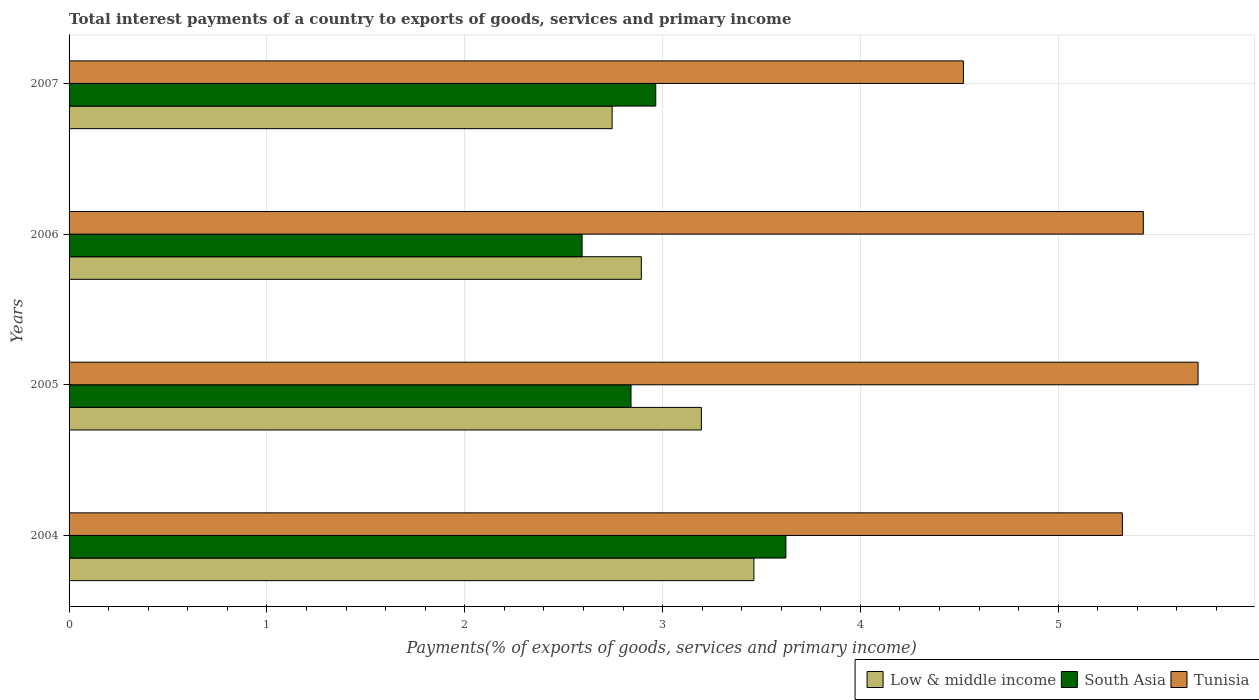How many different coloured bars are there?
Make the answer very short. 3. Are the number of bars per tick equal to the number of legend labels?
Ensure brevity in your answer.  Yes. Are the number of bars on each tick of the Y-axis equal?
Offer a terse response. Yes. How many bars are there on the 2nd tick from the top?
Make the answer very short. 3. How many bars are there on the 3rd tick from the bottom?
Offer a very short reply. 3. What is the label of the 3rd group of bars from the top?
Keep it short and to the point. 2005. In how many cases, is the number of bars for a given year not equal to the number of legend labels?
Your answer should be compact. 0. What is the total interest payments in Low & middle income in 2005?
Offer a very short reply. 3.2. Across all years, what is the maximum total interest payments in South Asia?
Keep it short and to the point. 3.62. Across all years, what is the minimum total interest payments in South Asia?
Give a very brief answer. 2.59. In which year was the total interest payments in Tunisia minimum?
Your response must be concise. 2007. What is the total total interest payments in Tunisia in the graph?
Give a very brief answer. 20.98. What is the difference between the total interest payments in Tunisia in 2005 and that in 2007?
Offer a terse response. 1.19. What is the difference between the total interest payments in South Asia in 2005 and the total interest payments in Tunisia in 2007?
Your answer should be very brief. -1.68. What is the average total interest payments in Tunisia per year?
Offer a terse response. 5.25. In the year 2004, what is the difference between the total interest payments in Tunisia and total interest payments in Low & middle income?
Your answer should be compact. 1.86. What is the ratio of the total interest payments in Low & middle income in 2005 to that in 2006?
Your answer should be compact. 1.1. Is the total interest payments in Low & middle income in 2004 less than that in 2007?
Provide a succinct answer. No. Is the difference between the total interest payments in Tunisia in 2006 and 2007 greater than the difference between the total interest payments in Low & middle income in 2006 and 2007?
Make the answer very short. Yes. What is the difference between the highest and the second highest total interest payments in Tunisia?
Offer a terse response. 0.28. What is the difference between the highest and the lowest total interest payments in Low & middle income?
Provide a succinct answer. 0.72. In how many years, is the total interest payments in Low & middle income greater than the average total interest payments in Low & middle income taken over all years?
Ensure brevity in your answer.  2. What does the 1st bar from the top in 2007 represents?
Your response must be concise. Tunisia. What does the 1st bar from the bottom in 2004 represents?
Your answer should be compact. Low & middle income. Is it the case that in every year, the sum of the total interest payments in South Asia and total interest payments in Tunisia is greater than the total interest payments in Low & middle income?
Your response must be concise. Yes. How many bars are there?
Your answer should be very brief. 12. Are all the bars in the graph horizontal?
Make the answer very short. Yes. What is the difference between two consecutive major ticks on the X-axis?
Keep it short and to the point. 1. Does the graph contain any zero values?
Your response must be concise. No. Does the graph contain grids?
Provide a short and direct response. Yes. Where does the legend appear in the graph?
Your answer should be compact. Bottom right. How many legend labels are there?
Your response must be concise. 3. How are the legend labels stacked?
Provide a succinct answer. Horizontal. What is the title of the graph?
Make the answer very short. Total interest payments of a country to exports of goods, services and primary income. What is the label or title of the X-axis?
Provide a succinct answer. Payments(% of exports of goods, services and primary income). What is the label or title of the Y-axis?
Your response must be concise. Years. What is the Payments(% of exports of goods, services and primary income) in Low & middle income in 2004?
Offer a very short reply. 3.46. What is the Payments(% of exports of goods, services and primary income) in South Asia in 2004?
Keep it short and to the point. 3.62. What is the Payments(% of exports of goods, services and primary income) in Tunisia in 2004?
Provide a succinct answer. 5.32. What is the Payments(% of exports of goods, services and primary income) in Low & middle income in 2005?
Offer a terse response. 3.2. What is the Payments(% of exports of goods, services and primary income) in South Asia in 2005?
Ensure brevity in your answer.  2.84. What is the Payments(% of exports of goods, services and primary income) in Tunisia in 2005?
Keep it short and to the point. 5.71. What is the Payments(% of exports of goods, services and primary income) in Low & middle income in 2006?
Offer a terse response. 2.89. What is the Payments(% of exports of goods, services and primary income) in South Asia in 2006?
Your response must be concise. 2.59. What is the Payments(% of exports of goods, services and primary income) in Tunisia in 2006?
Your answer should be compact. 5.43. What is the Payments(% of exports of goods, services and primary income) in Low & middle income in 2007?
Provide a short and direct response. 2.75. What is the Payments(% of exports of goods, services and primary income) in South Asia in 2007?
Your response must be concise. 2.97. What is the Payments(% of exports of goods, services and primary income) of Tunisia in 2007?
Give a very brief answer. 4.52. Across all years, what is the maximum Payments(% of exports of goods, services and primary income) of Low & middle income?
Provide a short and direct response. 3.46. Across all years, what is the maximum Payments(% of exports of goods, services and primary income) in South Asia?
Your answer should be compact. 3.62. Across all years, what is the maximum Payments(% of exports of goods, services and primary income) of Tunisia?
Keep it short and to the point. 5.71. Across all years, what is the minimum Payments(% of exports of goods, services and primary income) of Low & middle income?
Offer a terse response. 2.75. Across all years, what is the minimum Payments(% of exports of goods, services and primary income) in South Asia?
Give a very brief answer. 2.59. Across all years, what is the minimum Payments(% of exports of goods, services and primary income) of Tunisia?
Make the answer very short. 4.52. What is the total Payments(% of exports of goods, services and primary income) of Low & middle income in the graph?
Your response must be concise. 12.3. What is the total Payments(% of exports of goods, services and primary income) in South Asia in the graph?
Keep it short and to the point. 12.02. What is the total Payments(% of exports of goods, services and primary income) in Tunisia in the graph?
Make the answer very short. 20.98. What is the difference between the Payments(% of exports of goods, services and primary income) in Low & middle income in 2004 and that in 2005?
Your answer should be very brief. 0.27. What is the difference between the Payments(% of exports of goods, services and primary income) in South Asia in 2004 and that in 2005?
Give a very brief answer. 0.78. What is the difference between the Payments(% of exports of goods, services and primary income) in Tunisia in 2004 and that in 2005?
Your answer should be very brief. -0.38. What is the difference between the Payments(% of exports of goods, services and primary income) of Low & middle income in 2004 and that in 2006?
Provide a short and direct response. 0.57. What is the difference between the Payments(% of exports of goods, services and primary income) of South Asia in 2004 and that in 2006?
Provide a short and direct response. 1.03. What is the difference between the Payments(% of exports of goods, services and primary income) in Tunisia in 2004 and that in 2006?
Provide a succinct answer. -0.11. What is the difference between the Payments(% of exports of goods, services and primary income) of Low & middle income in 2004 and that in 2007?
Make the answer very short. 0.72. What is the difference between the Payments(% of exports of goods, services and primary income) of South Asia in 2004 and that in 2007?
Your response must be concise. 0.66. What is the difference between the Payments(% of exports of goods, services and primary income) of Tunisia in 2004 and that in 2007?
Offer a terse response. 0.8. What is the difference between the Payments(% of exports of goods, services and primary income) of Low & middle income in 2005 and that in 2006?
Offer a very short reply. 0.3. What is the difference between the Payments(% of exports of goods, services and primary income) in South Asia in 2005 and that in 2006?
Make the answer very short. 0.25. What is the difference between the Payments(% of exports of goods, services and primary income) in Tunisia in 2005 and that in 2006?
Ensure brevity in your answer.  0.28. What is the difference between the Payments(% of exports of goods, services and primary income) in Low & middle income in 2005 and that in 2007?
Your answer should be very brief. 0.45. What is the difference between the Payments(% of exports of goods, services and primary income) of South Asia in 2005 and that in 2007?
Your answer should be compact. -0.12. What is the difference between the Payments(% of exports of goods, services and primary income) in Tunisia in 2005 and that in 2007?
Your answer should be compact. 1.19. What is the difference between the Payments(% of exports of goods, services and primary income) of Low & middle income in 2006 and that in 2007?
Your answer should be very brief. 0.15. What is the difference between the Payments(% of exports of goods, services and primary income) in South Asia in 2006 and that in 2007?
Ensure brevity in your answer.  -0.37. What is the difference between the Payments(% of exports of goods, services and primary income) in Tunisia in 2006 and that in 2007?
Offer a very short reply. 0.91. What is the difference between the Payments(% of exports of goods, services and primary income) in Low & middle income in 2004 and the Payments(% of exports of goods, services and primary income) in South Asia in 2005?
Ensure brevity in your answer.  0.62. What is the difference between the Payments(% of exports of goods, services and primary income) of Low & middle income in 2004 and the Payments(% of exports of goods, services and primary income) of Tunisia in 2005?
Keep it short and to the point. -2.25. What is the difference between the Payments(% of exports of goods, services and primary income) in South Asia in 2004 and the Payments(% of exports of goods, services and primary income) in Tunisia in 2005?
Ensure brevity in your answer.  -2.08. What is the difference between the Payments(% of exports of goods, services and primary income) in Low & middle income in 2004 and the Payments(% of exports of goods, services and primary income) in South Asia in 2006?
Provide a short and direct response. 0.87. What is the difference between the Payments(% of exports of goods, services and primary income) in Low & middle income in 2004 and the Payments(% of exports of goods, services and primary income) in Tunisia in 2006?
Make the answer very short. -1.97. What is the difference between the Payments(% of exports of goods, services and primary income) in South Asia in 2004 and the Payments(% of exports of goods, services and primary income) in Tunisia in 2006?
Keep it short and to the point. -1.81. What is the difference between the Payments(% of exports of goods, services and primary income) of Low & middle income in 2004 and the Payments(% of exports of goods, services and primary income) of South Asia in 2007?
Your response must be concise. 0.5. What is the difference between the Payments(% of exports of goods, services and primary income) of Low & middle income in 2004 and the Payments(% of exports of goods, services and primary income) of Tunisia in 2007?
Provide a short and direct response. -1.06. What is the difference between the Payments(% of exports of goods, services and primary income) in South Asia in 2004 and the Payments(% of exports of goods, services and primary income) in Tunisia in 2007?
Ensure brevity in your answer.  -0.9. What is the difference between the Payments(% of exports of goods, services and primary income) in Low & middle income in 2005 and the Payments(% of exports of goods, services and primary income) in South Asia in 2006?
Provide a succinct answer. 0.6. What is the difference between the Payments(% of exports of goods, services and primary income) in Low & middle income in 2005 and the Payments(% of exports of goods, services and primary income) in Tunisia in 2006?
Your response must be concise. -2.23. What is the difference between the Payments(% of exports of goods, services and primary income) of South Asia in 2005 and the Payments(% of exports of goods, services and primary income) of Tunisia in 2006?
Ensure brevity in your answer.  -2.59. What is the difference between the Payments(% of exports of goods, services and primary income) in Low & middle income in 2005 and the Payments(% of exports of goods, services and primary income) in South Asia in 2007?
Your answer should be compact. 0.23. What is the difference between the Payments(% of exports of goods, services and primary income) in Low & middle income in 2005 and the Payments(% of exports of goods, services and primary income) in Tunisia in 2007?
Offer a terse response. -1.32. What is the difference between the Payments(% of exports of goods, services and primary income) in South Asia in 2005 and the Payments(% of exports of goods, services and primary income) in Tunisia in 2007?
Offer a terse response. -1.68. What is the difference between the Payments(% of exports of goods, services and primary income) in Low & middle income in 2006 and the Payments(% of exports of goods, services and primary income) in South Asia in 2007?
Provide a short and direct response. -0.07. What is the difference between the Payments(% of exports of goods, services and primary income) in Low & middle income in 2006 and the Payments(% of exports of goods, services and primary income) in Tunisia in 2007?
Provide a succinct answer. -1.63. What is the difference between the Payments(% of exports of goods, services and primary income) in South Asia in 2006 and the Payments(% of exports of goods, services and primary income) in Tunisia in 2007?
Offer a very short reply. -1.93. What is the average Payments(% of exports of goods, services and primary income) in Low & middle income per year?
Give a very brief answer. 3.07. What is the average Payments(% of exports of goods, services and primary income) in South Asia per year?
Give a very brief answer. 3.01. What is the average Payments(% of exports of goods, services and primary income) in Tunisia per year?
Provide a succinct answer. 5.25. In the year 2004, what is the difference between the Payments(% of exports of goods, services and primary income) in Low & middle income and Payments(% of exports of goods, services and primary income) in South Asia?
Offer a terse response. -0.16. In the year 2004, what is the difference between the Payments(% of exports of goods, services and primary income) in Low & middle income and Payments(% of exports of goods, services and primary income) in Tunisia?
Keep it short and to the point. -1.86. In the year 2004, what is the difference between the Payments(% of exports of goods, services and primary income) in South Asia and Payments(% of exports of goods, services and primary income) in Tunisia?
Provide a short and direct response. -1.7. In the year 2005, what is the difference between the Payments(% of exports of goods, services and primary income) of Low & middle income and Payments(% of exports of goods, services and primary income) of South Asia?
Keep it short and to the point. 0.36. In the year 2005, what is the difference between the Payments(% of exports of goods, services and primary income) of Low & middle income and Payments(% of exports of goods, services and primary income) of Tunisia?
Provide a succinct answer. -2.51. In the year 2005, what is the difference between the Payments(% of exports of goods, services and primary income) in South Asia and Payments(% of exports of goods, services and primary income) in Tunisia?
Ensure brevity in your answer.  -2.87. In the year 2006, what is the difference between the Payments(% of exports of goods, services and primary income) of Low & middle income and Payments(% of exports of goods, services and primary income) of South Asia?
Your response must be concise. 0.3. In the year 2006, what is the difference between the Payments(% of exports of goods, services and primary income) in Low & middle income and Payments(% of exports of goods, services and primary income) in Tunisia?
Keep it short and to the point. -2.54. In the year 2006, what is the difference between the Payments(% of exports of goods, services and primary income) of South Asia and Payments(% of exports of goods, services and primary income) of Tunisia?
Your answer should be compact. -2.84. In the year 2007, what is the difference between the Payments(% of exports of goods, services and primary income) of Low & middle income and Payments(% of exports of goods, services and primary income) of South Asia?
Ensure brevity in your answer.  -0.22. In the year 2007, what is the difference between the Payments(% of exports of goods, services and primary income) in Low & middle income and Payments(% of exports of goods, services and primary income) in Tunisia?
Your answer should be very brief. -1.78. In the year 2007, what is the difference between the Payments(% of exports of goods, services and primary income) in South Asia and Payments(% of exports of goods, services and primary income) in Tunisia?
Give a very brief answer. -1.56. What is the ratio of the Payments(% of exports of goods, services and primary income) of Low & middle income in 2004 to that in 2005?
Ensure brevity in your answer.  1.08. What is the ratio of the Payments(% of exports of goods, services and primary income) in South Asia in 2004 to that in 2005?
Provide a succinct answer. 1.28. What is the ratio of the Payments(% of exports of goods, services and primary income) in Tunisia in 2004 to that in 2005?
Provide a succinct answer. 0.93. What is the ratio of the Payments(% of exports of goods, services and primary income) in Low & middle income in 2004 to that in 2006?
Offer a terse response. 1.2. What is the ratio of the Payments(% of exports of goods, services and primary income) in South Asia in 2004 to that in 2006?
Offer a terse response. 1.4. What is the ratio of the Payments(% of exports of goods, services and primary income) in Tunisia in 2004 to that in 2006?
Keep it short and to the point. 0.98. What is the ratio of the Payments(% of exports of goods, services and primary income) of Low & middle income in 2004 to that in 2007?
Keep it short and to the point. 1.26. What is the ratio of the Payments(% of exports of goods, services and primary income) of South Asia in 2004 to that in 2007?
Your answer should be compact. 1.22. What is the ratio of the Payments(% of exports of goods, services and primary income) of Tunisia in 2004 to that in 2007?
Give a very brief answer. 1.18. What is the ratio of the Payments(% of exports of goods, services and primary income) in Low & middle income in 2005 to that in 2006?
Provide a short and direct response. 1.1. What is the ratio of the Payments(% of exports of goods, services and primary income) of South Asia in 2005 to that in 2006?
Provide a short and direct response. 1.1. What is the ratio of the Payments(% of exports of goods, services and primary income) of Tunisia in 2005 to that in 2006?
Keep it short and to the point. 1.05. What is the ratio of the Payments(% of exports of goods, services and primary income) in Low & middle income in 2005 to that in 2007?
Ensure brevity in your answer.  1.16. What is the ratio of the Payments(% of exports of goods, services and primary income) in South Asia in 2005 to that in 2007?
Your response must be concise. 0.96. What is the ratio of the Payments(% of exports of goods, services and primary income) in Tunisia in 2005 to that in 2007?
Make the answer very short. 1.26. What is the ratio of the Payments(% of exports of goods, services and primary income) of Low & middle income in 2006 to that in 2007?
Provide a succinct answer. 1.05. What is the ratio of the Payments(% of exports of goods, services and primary income) of South Asia in 2006 to that in 2007?
Make the answer very short. 0.87. What is the ratio of the Payments(% of exports of goods, services and primary income) in Tunisia in 2006 to that in 2007?
Your answer should be compact. 1.2. What is the difference between the highest and the second highest Payments(% of exports of goods, services and primary income) of Low & middle income?
Provide a short and direct response. 0.27. What is the difference between the highest and the second highest Payments(% of exports of goods, services and primary income) in South Asia?
Offer a very short reply. 0.66. What is the difference between the highest and the second highest Payments(% of exports of goods, services and primary income) of Tunisia?
Offer a very short reply. 0.28. What is the difference between the highest and the lowest Payments(% of exports of goods, services and primary income) of Low & middle income?
Keep it short and to the point. 0.72. What is the difference between the highest and the lowest Payments(% of exports of goods, services and primary income) in South Asia?
Give a very brief answer. 1.03. What is the difference between the highest and the lowest Payments(% of exports of goods, services and primary income) of Tunisia?
Offer a very short reply. 1.19. 